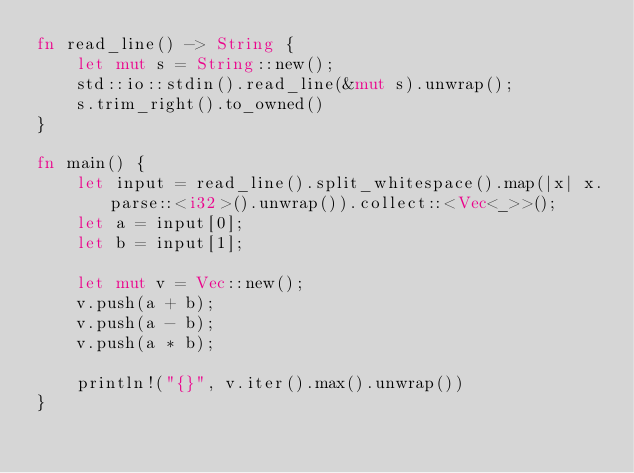<code> <loc_0><loc_0><loc_500><loc_500><_Rust_>fn read_line() -> String {
    let mut s = String::new();
    std::io::stdin().read_line(&mut s).unwrap();
    s.trim_right().to_owned()
}

fn main() {
    let input = read_line().split_whitespace().map(|x| x.parse::<i32>().unwrap()).collect::<Vec<_>>();
    let a = input[0];
    let b = input[1];

    let mut v = Vec::new();
    v.push(a + b);
    v.push(a - b);
    v.push(a * b);
    
    println!("{}", v.iter().max().unwrap())
}</code> 